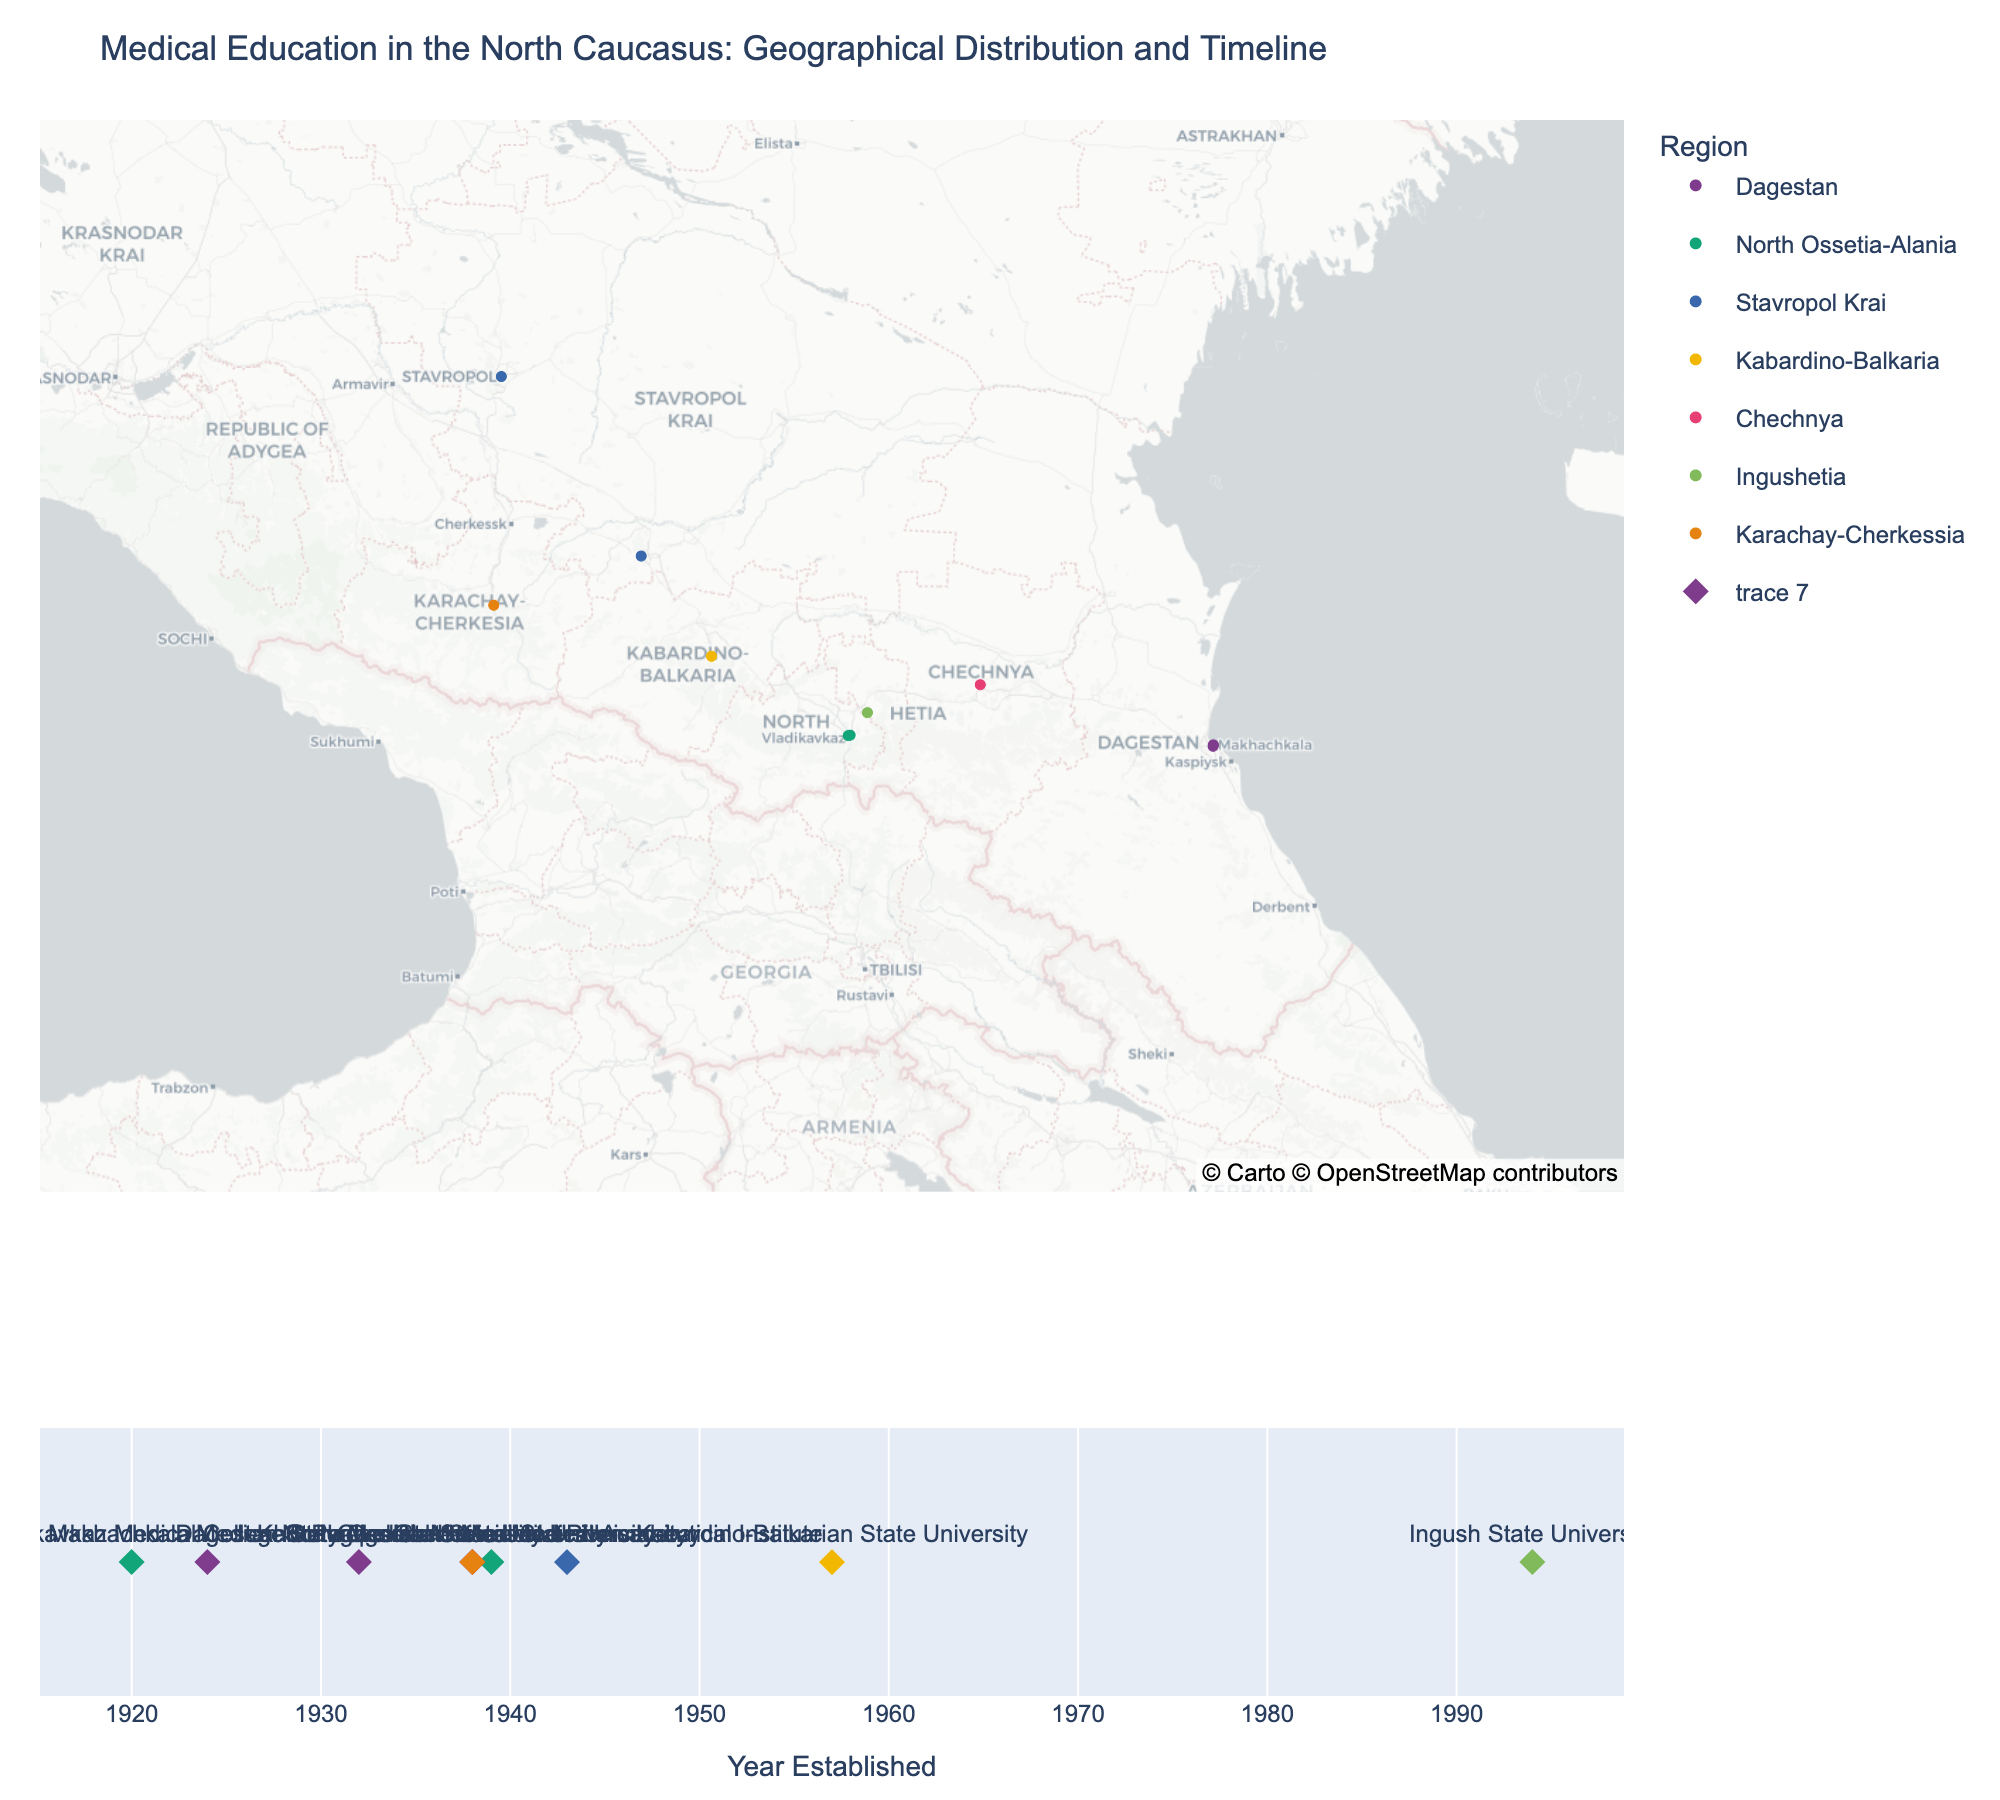How many medical education centers in the North Caucasus are displayed on the map? There are 10 institutions listed in the dataset, each represented by a data point on the map. The number can be counted either directly from the map or by counting the rows in the dataset.
Answer: 10 Which city has the highest number of medical education institutions listed in the map? By analyzing the map and dataset, we notice that Makhachkala has two institutions: Dagestan State Medical University and Makhachkala Medical College, while other cities have only one.
Answer: Makhachkala What is the oldest active medical education center in the North Caucasus as shown on the timeline? The timeline shows the establishment years for each institution. The oldest one, established in 1920, is the Vladikavkaz Medical College.
Answer: Vladikavkaz Medical College Which region has the most medical education institutions on the map? By reviewing the map and categorizing based on the regions, Dagestan stands out with two institutions: Dagestan State Medical University and Makhachkala Medical College. Other regions have only one institution each.
Answer: Dagestan Between 1938 and 1943, how many medical education centers were established? Using the timeline, we identify the institutions established within those years: Stavropol State Medical University, Chechen State University, Karachaevo-Cherkessia State University, and Pyatigorsk Medical and Pharmaceutical Institute. Therefore, there are four such institutions.
Answer: 4 What color represents the Dagestan region on the map? By checking the color legend for the region 'Dagestan' on the map, we find a specific color corresponding to it. The plotly color scheme indicates it as a certain shade, identified by looking at the color dot alongside the label 'Dagestan' in the legend.
Answer: (This would depend on the color map used; replace with appropriate color if known, e.g., 'blue') Compare the establishment years of the Dagestan State Medical University and the North Ossetian State Medical Academy. Which one is older? Referring to the timeline and dataset, the Dagestan State Medical University was established in 1932, while the North Ossetian State Medical Academy was established later in 1939.
Answer: Dagestan State Medical University Which is the newest institution on the map, and in which year was it established? From the timeline, the newest institution is the Ingush State University, established in 1994.
Answer: Ingush State University (1994) How many medical education centers were established by 1950? By scanning the timeline for institutions established up to 1950, we count six: Vladikavkaz Medical College, Makhachkala Medical College, Dagestan State Medical University, Stavropol State Medical University, Chechen State University, Karachaevo-Cherkessia State University.
Answer: 6 What is the range of establishment years for the medical education centers displayed on the map? The establishment dates range from the earliest institution in 1920 to the latest in 1994, spanning a period of 74 years.
Answer: 1920 to 1994 (74 years) 